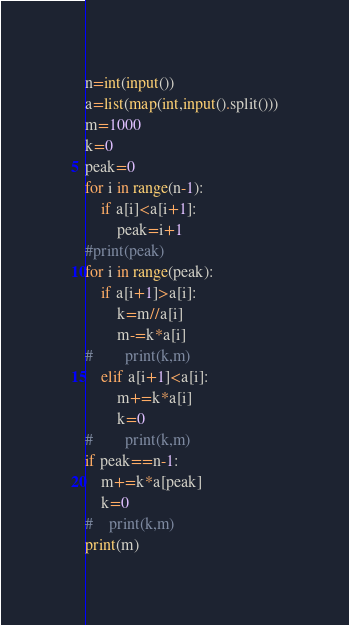Convert code to text. <code><loc_0><loc_0><loc_500><loc_500><_Python_>n=int(input())
a=list(map(int,input().split()))
m=1000
k=0
peak=0
for i in range(n-1):
    if a[i]<a[i+1]:
        peak=i+1
#print(peak)
for i in range(peak):
    if a[i+1]>a[i]:
        k=m//a[i]
        m-=k*a[i]
#        print(k,m)
    elif a[i+1]<a[i]:
        m+=k*a[i]
        k=0
#        print(k,m)
if peak==n-1:
    m+=k*a[peak]
    k=0
#    print(k,m)
print(m)</code> 